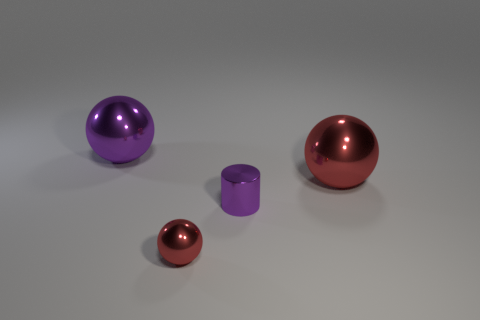Could these objects be part of a larger set or collection? Yes, it's plausible that these objects could be part of a set, perhaps a collection of decorative items or educational models demonstrating geometric shapes and volumes. 